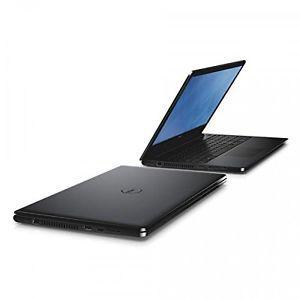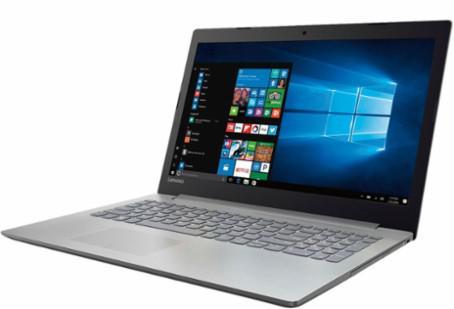The first image is the image on the left, the second image is the image on the right. For the images displayed, is the sentence "The lids of all laptop computers are fully upright." factually correct? Answer yes or no. No. 